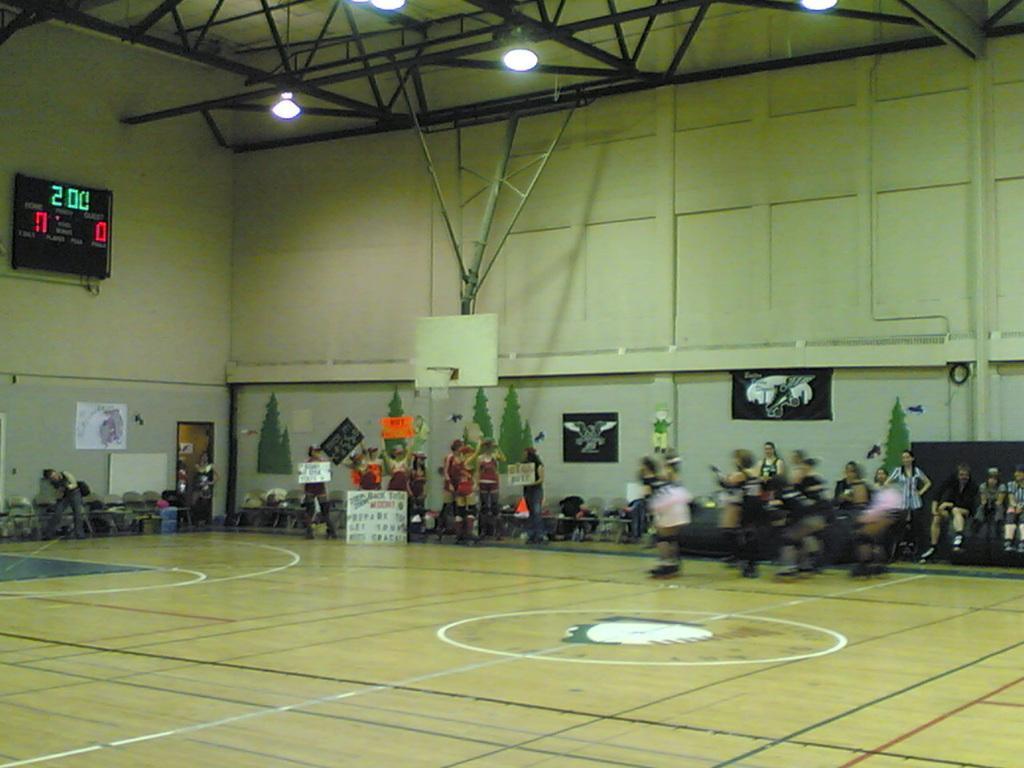How would you summarize this image in a sentence or two? In this image we can see persons standing on the floor. In the background we can see display screens, iron grills, electric lights, walls, pictures pasted on the wall and margins on the floor. 